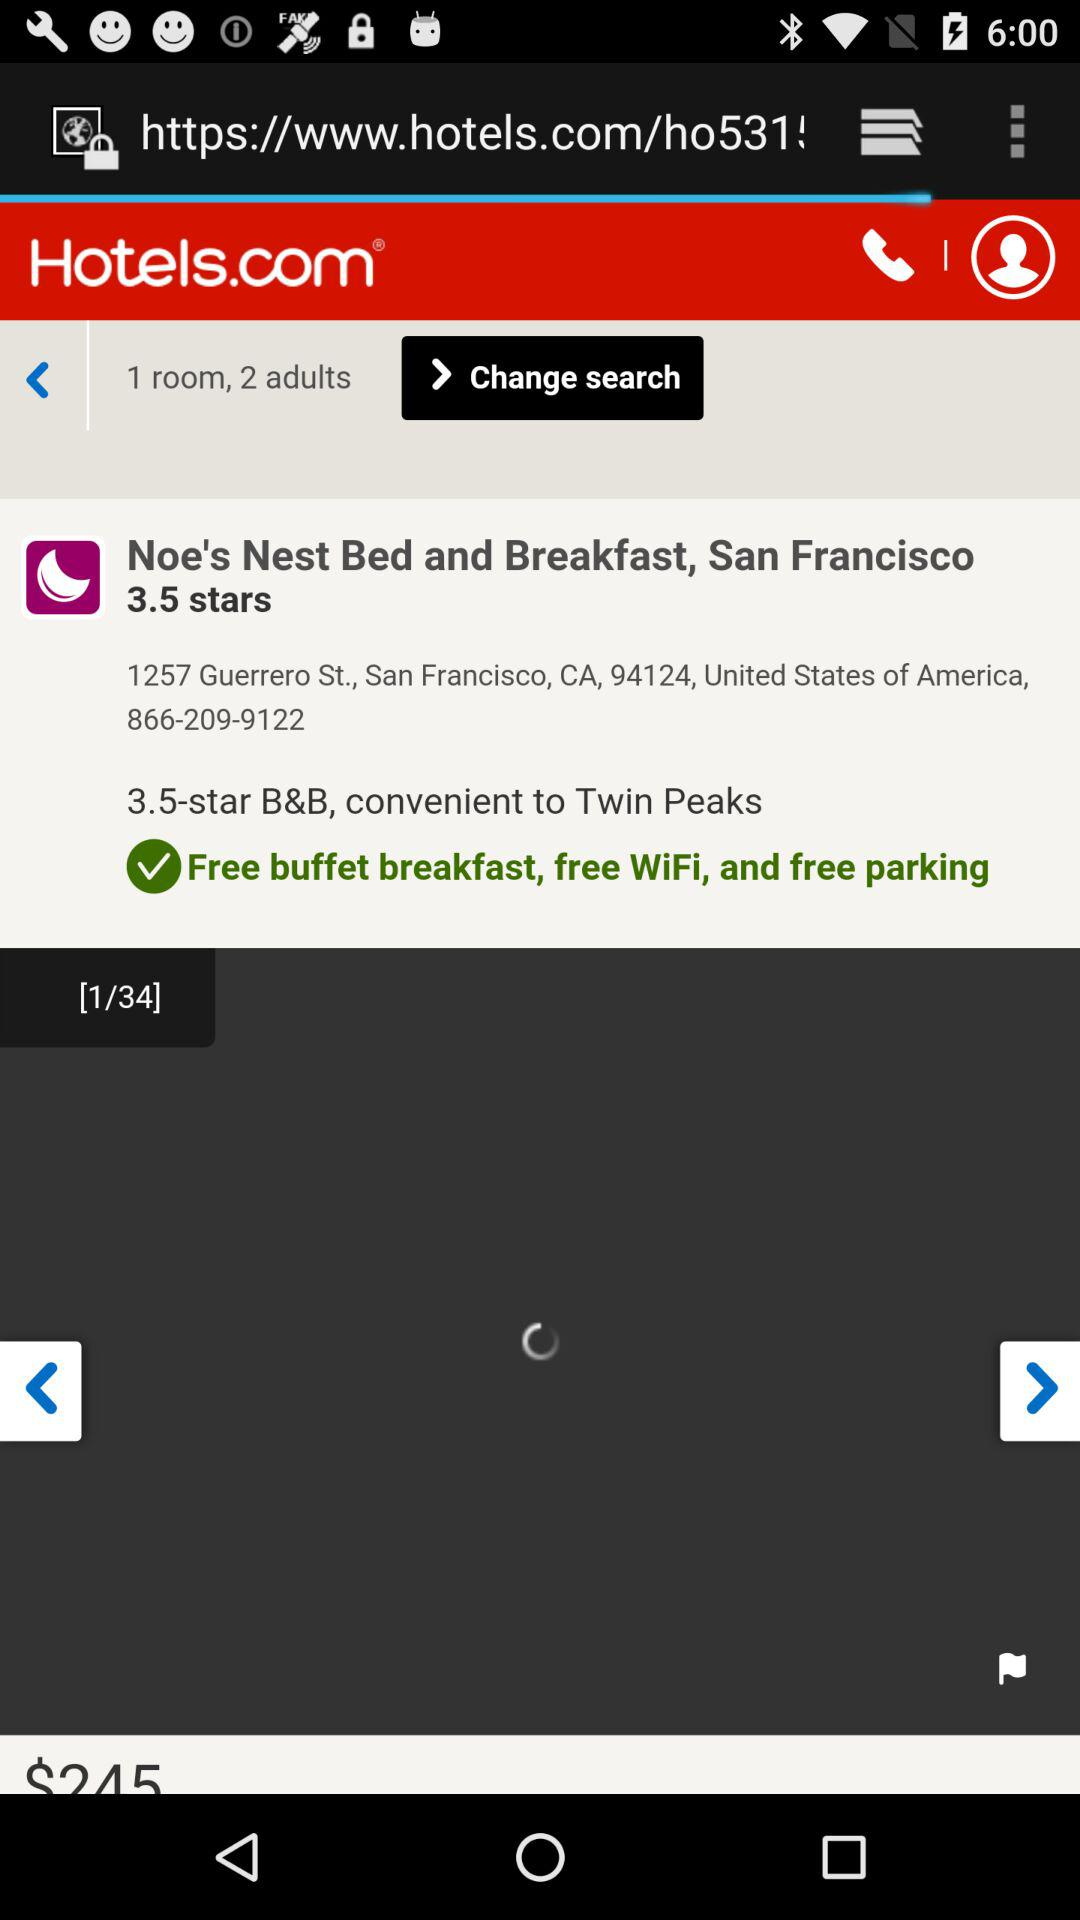What is the selected number of adults? The selected number of adults is 2. 